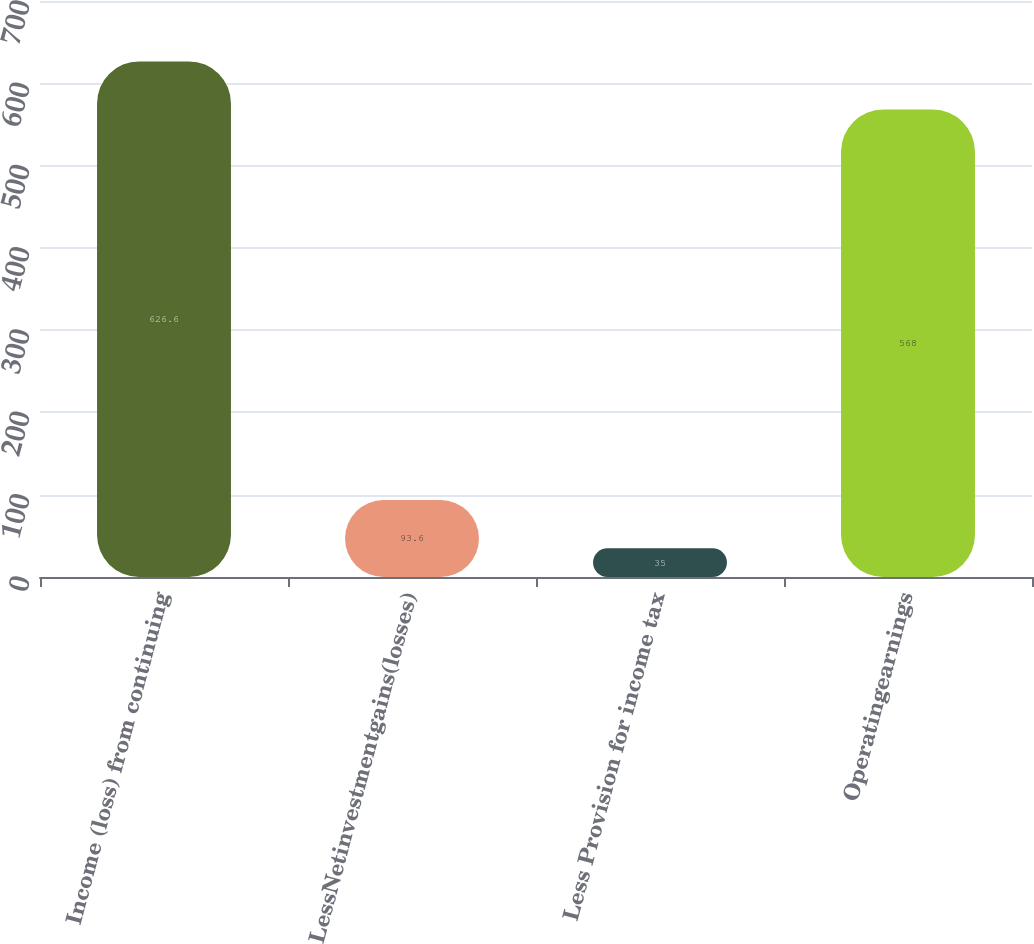Convert chart. <chart><loc_0><loc_0><loc_500><loc_500><bar_chart><fcel>Income (loss) from continuing<fcel>LessNetinvestmentgains(losses)<fcel>Less Provision for income tax<fcel>Operatingearnings<nl><fcel>626.6<fcel>93.6<fcel>35<fcel>568<nl></chart> 